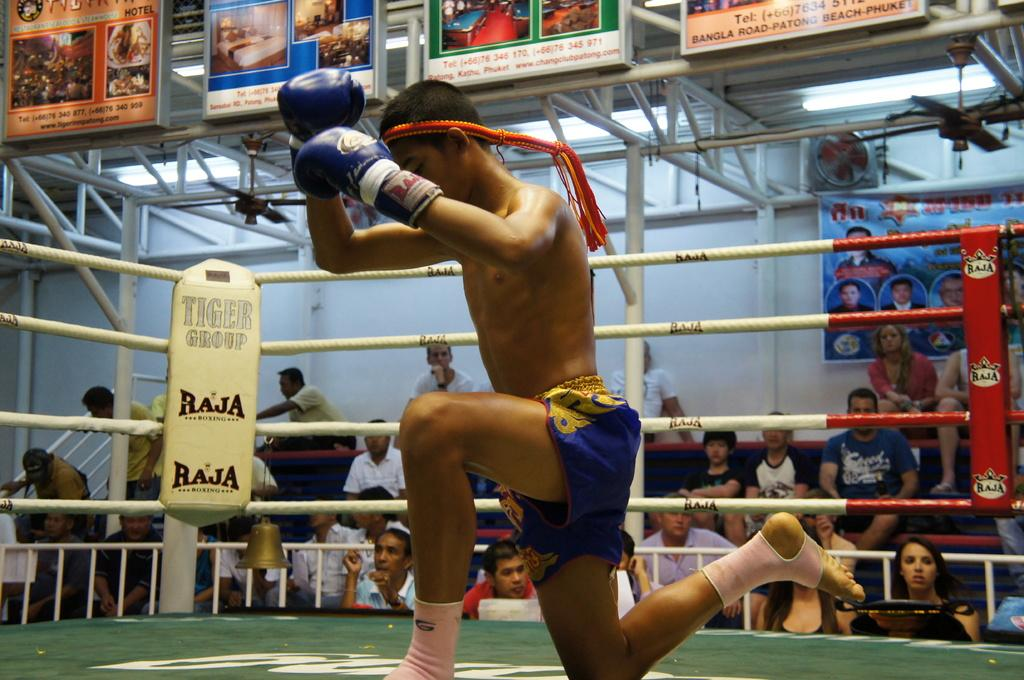<image>
Share a concise interpretation of the image provided. The corner of a boxing ring states Tiger Group. 